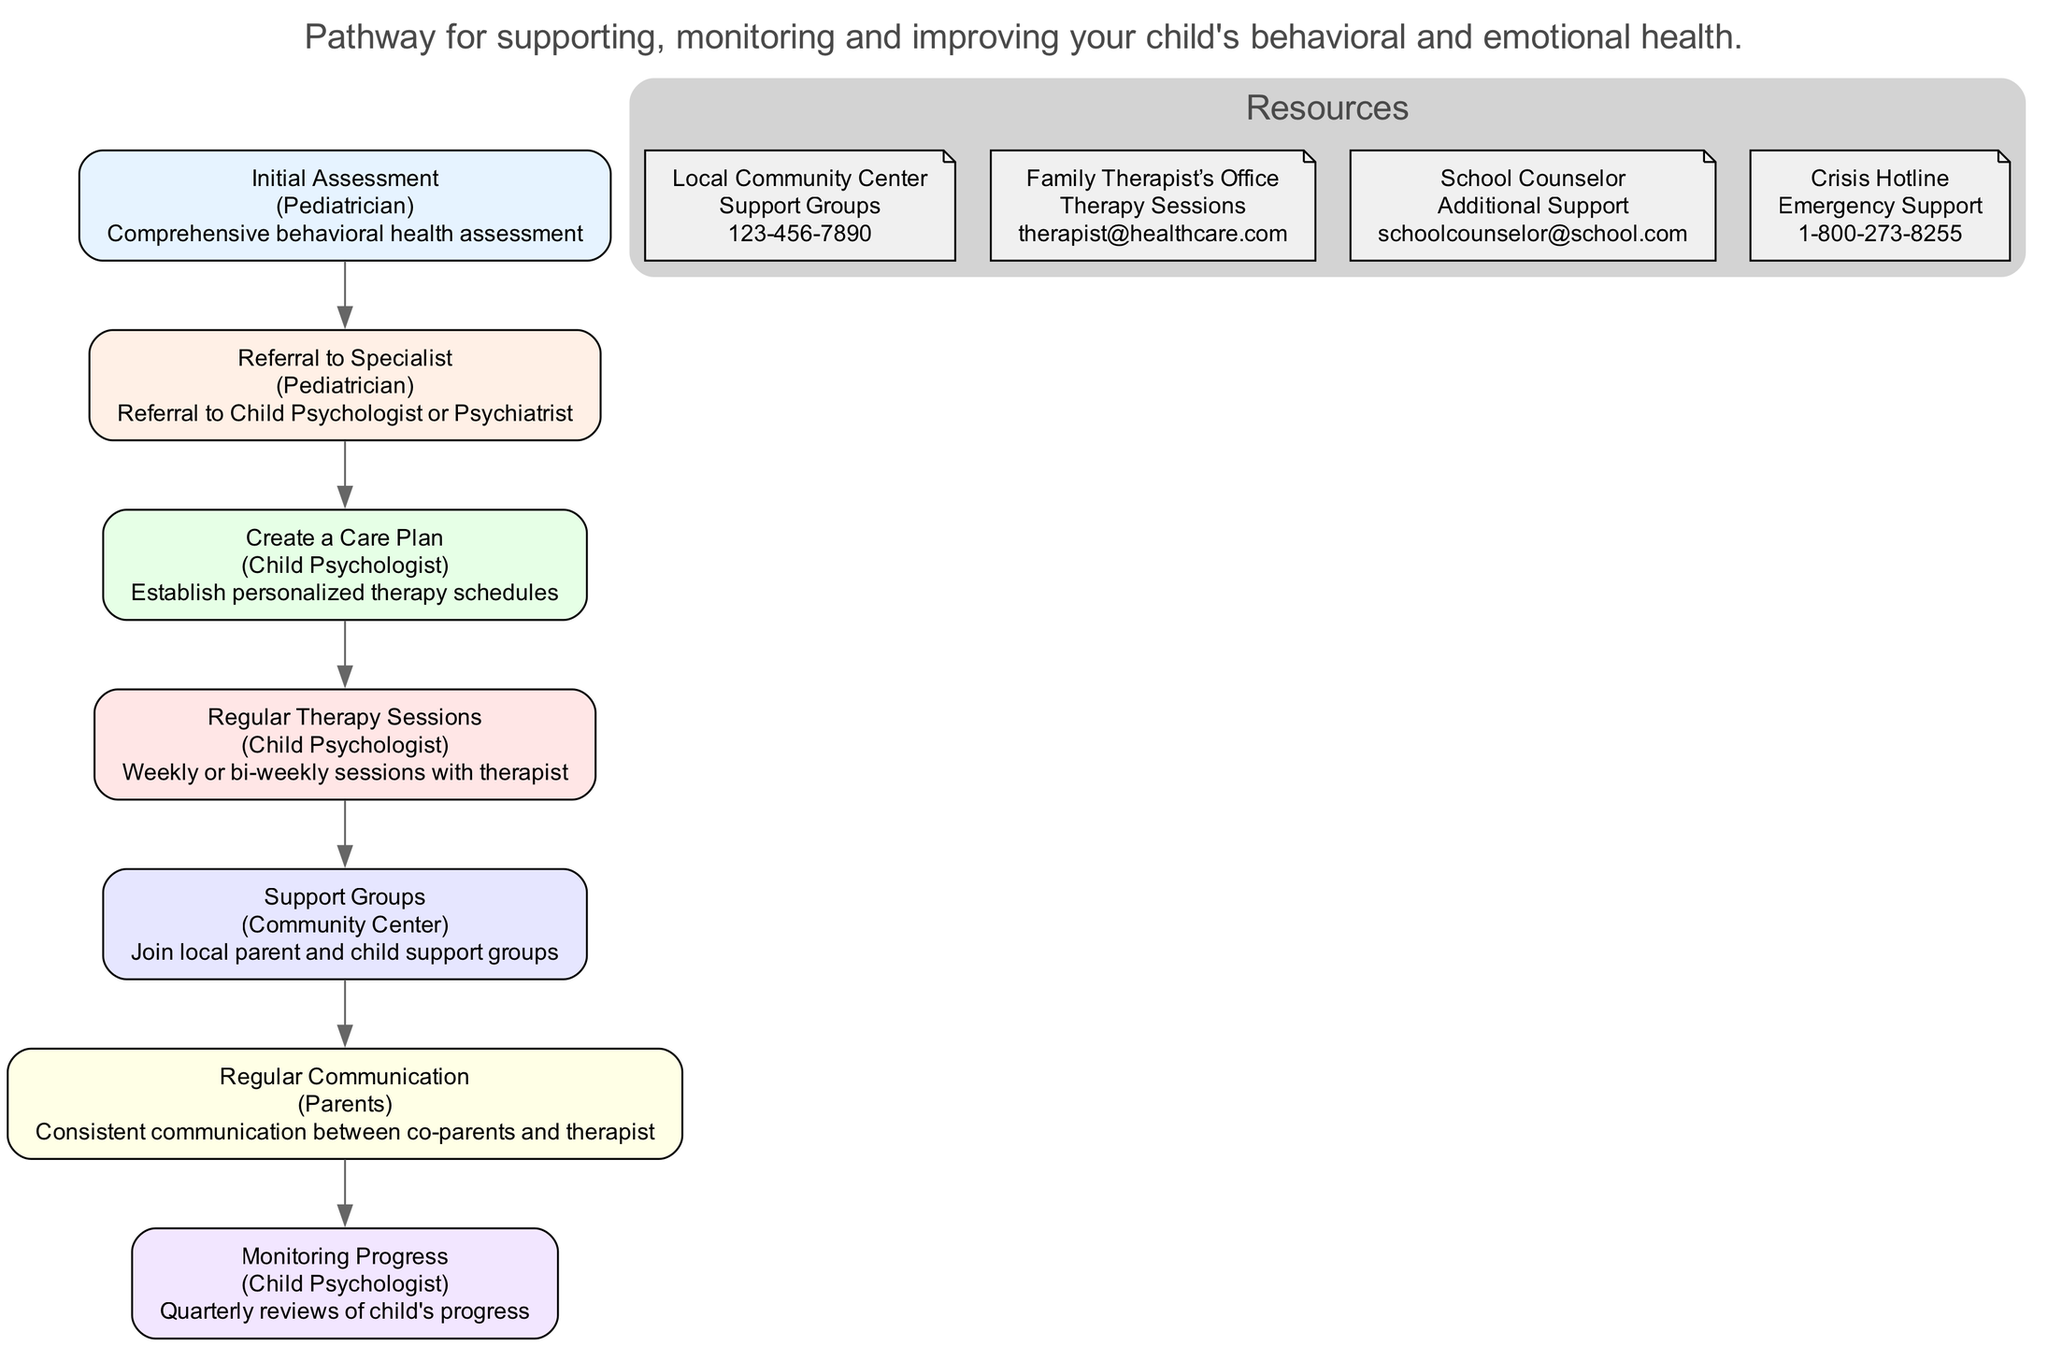What is the first step in the pathway? The first step in the pathway is identified in the diagram, which shows "Initial Assessment" as the starting point.
Answer: Initial Assessment Who is responsible for the "Regular Communication"? The diagram indicates that "Parents" are responsible for this step, as it shows "Regular Communication" linked to the parents.
Answer: Parents How many therapy sessions are typically scheduled? The diagram describes "Weekly or bi-weekly sessions with therapist" for the therapy sessions, implying they occur often.
Answer: Weekly or bi-weekly What is the purpose of the "Monitoring Progress" step? The diagram makes it clear that this step is connected to "Quarterly reviews of child's progress," indicating its purpose is to evaluate progress.
Answer: Quarterly reviews of child's progress Which entity provides "Support Groups"? "Community Center" is mentioned in association with the "Support Groups" step, showing it as the provider of this resource.
Answer: Community Center What resources are available for emergency support? The diagram specifies a "Crisis Hotline" as an available resource for emergency support, indicating its importance in urgent situations.
Answer: Crisis Hotline Which step comes after the "Referral to Specialist"? The flow in the diagram indicates the next step is "Create a Care Plan" immediately following the "Referral to Specialist."
Answer: Create a Care Plan How often does the Child Psychologist review progress? The diagram indicates that the reviews occur quarterly, showing how often the progress is monitored during this step.
Answer: Quarterly What type of groups does the Community Center provide? The diagram states that the Community Center offers "parent and child support groups," highlighting the type of groups available.
Answer: Parent and child support groups 